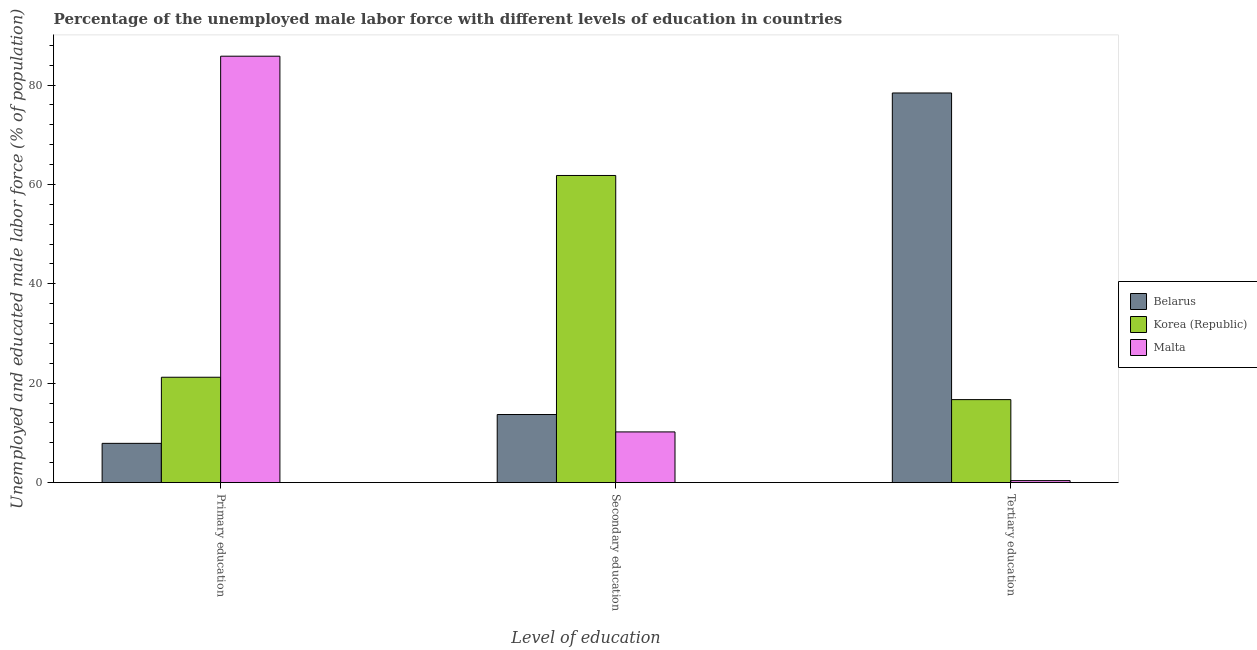How many groups of bars are there?
Your response must be concise. 3. Are the number of bars per tick equal to the number of legend labels?
Keep it short and to the point. Yes. Are the number of bars on each tick of the X-axis equal?
Your answer should be very brief. Yes. How many bars are there on the 1st tick from the left?
Ensure brevity in your answer.  3. How many bars are there on the 2nd tick from the right?
Your response must be concise. 3. What is the label of the 3rd group of bars from the left?
Provide a succinct answer. Tertiary education. What is the percentage of male labor force who received tertiary education in Belarus?
Provide a short and direct response. 78.4. Across all countries, what is the maximum percentage of male labor force who received secondary education?
Ensure brevity in your answer.  61.8. Across all countries, what is the minimum percentage of male labor force who received tertiary education?
Your response must be concise. 0.4. In which country was the percentage of male labor force who received secondary education minimum?
Give a very brief answer. Malta. What is the total percentage of male labor force who received primary education in the graph?
Ensure brevity in your answer.  114.9. What is the difference between the percentage of male labor force who received tertiary education in Korea (Republic) and that in Malta?
Make the answer very short. 16.3. What is the difference between the percentage of male labor force who received secondary education in Korea (Republic) and the percentage of male labor force who received tertiary education in Malta?
Make the answer very short. 61.4. What is the average percentage of male labor force who received secondary education per country?
Your response must be concise. 28.57. What is the difference between the percentage of male labor force who received primary education and percentage of male labor force who received tertiary education in Malta?
Make the answer very short. 85.4. In how many countries, is the percentage of male labor force who received secondary education greater than 44 %?
Give a very brief answer. 1. What is the ratio of the percentage of male labor force who received primary education in Malta to that in Korea (Republic)?
Your response must be concise. 4.05. Is the percentage of male labor force who received primary education in Belarus less than that in Korea (Republic)?
Provide a succinct answer. Yes. Is the difference between the percentage of male labor force who received primary education in Korea (Republic) and Malta greater than the difference between the percentage of male labor force who received secondary education in Korea (Republic) and Malta?
Provide a succinct answer. No. What is the difference between the highest and the second highest percentage of male labor force who received tertiary education?
Offer a very short reply. 61.7. What is the difference between the highest and the lowest percentage of male labor force who received primary education?
Keep it short and to the point. 77.9. Is the sum of the percentage of male labor force who received tertiary education in Malta and Belarus greater than the maximum percentage of male labor force who received primary education across all countries?
Your answer should be compact. No. What does the 3rd bar from the left in Secondary education represents?
Your answer should be very brief. Malta. What does the 1st bar from the right in Secondary education represents?
Keep it short and to the point. Malta. Is it the case that in every country, the sum of the percentage of male labor force who received primary education and percentage of male labor force who received secondary education is greater than the percentage of male labor force who received tertiary education?
Your answer should be very brief. No. How many bars are there?
Give a very brief answer. 9. How many countries are there in the graph?
Provide a short and direct response. 3. What is the difference between two consecutive major ticks on the Y-axis?
Your response must be concise. 20. Are the values on the major ticks of Y-axis written in scientific E-notation?
Offer a terse response. No. Where does the legend appear in the graph?
Keep it short and to the point. Center right. What is the title of the graph?
Offer a very short reply. Percentage of the unemployed male labor force with different levels of education in countries. Does "North America" appear as one of the legend labels in the graph?
Offer a terse response. No. What is the label or title of the X-axis?
Offer a very short reply. Level of education. What is the label or title of the Y-axis?
Your answer should be very brief. Unemployed and educated male labor force (% of population). What is the Unemployed and educated male labor force (% of population) in Belarus in Primary education?
Ensure brevity in your answer.  7.9. What is the Unemployed and educated male labor force (% of population) in Korea (Republic) in Primary education?
Your answer should be very brief. 21.2. What is the Unemployed and educated male labor force (% of population) in Malta in Primary education?
Keep it short and to the point. 85.8. What is the Unemployed and educated male labor force (% of population) in Belarus in Secondary education?
Ensure brevity in your answer.  13.7. What is the Unemployed and educated male labor force (% of population) of Korea (Republic) in Secondary education?
Provide a short and direct response. 61.8. What is the Unemployed and educated male labor force (% of population) of Malta in Secondary education?
Ensure brevity in your answer.  10.2. What is the Unemployed and educated male labor force (% of population) in Belarus in Tertiary education?
Provide a succinct answer. 78.4. What is the Unemployed and educated male labor force (% of population) in Korea (Republic) in Tertiary education?
Your answer should be compact. 16.7. What is the Unemployed and educated male labor force (% of population) of Malta in Tertiary education?
Your response must be concise. 0.4. Across all Level of education, what is the maximum Unemployed and educated male labor force (% of population) in Belarus?
Your answer should be compact. 78.4. Across all Level of education, what is the maximum Unemployed and educated male labor force (% of population) of Korea (Republic)?
Your response must be concise. 61.8. Across all Level of education, what is the maximum Unemployed and educated male labor force (% of population) of Malta?
Your answer should be very brief. 85.8. Across all Level of education, what is the minimum Unemployed and educated male labor force (% of population) in Belarus?
Make the answer very short. 7.9. Across all Level of education, what is the minimum Unemployed and educated male labor force (% of population) of Korea (Republic)?
Ensure brevity in your answer.  16.7. Across all Level of education, what is the minimum Unemployed and educated male labor force (% of population) in Malta?
Offer a very short reply. 0.4. What is the total Unemployed and educated male labor force (% of population) of Korea (Republic) in the graph?
Give a very brief answer. 99.7. What is the total Unemployed and educated male labor force (% of population) of Malta in the graph?
Keep it short and to the point. 96.4. What is the difference between the Unemployed and educated male labor force (% of population) in Korea (Republic) in Primary education and that in Secondary education?
Your answer should be compact. -40.6. What is the difference between the Unemployed and educated male labor force (% of population) of Malta in Primary education and that in Secondary education?
Provide a succinct answer. 75.6. What is the difference between the Unemployed and educated male labor force (% of population) in Belarus in Primary education and that in Tertiary education?
Provide a succinct answer. -70.5. What is the difference between the Unemployed and educated male labor force (% of population) of Korea (Republic) in Primary education and that in Tertiary education?
Ensure brevity in your answer.  4.5. What is the difference between the Unemployed and educated male labor force (% of population) in Malta in Primary education and that in Tertiary education?
Your response must be concise. 85.4. What is the difference between the Unemployed and educated male labor force (% of population) of Belarus in Secondary education and that in Tertiary education?
Make the answer very short. -64.7. What is the difference between the Unemployed and educated male labor force (% of population) of Korea (Republic) in Secondary education and that in Tertiary education?
Offer a terse response. 45.1. What is the difference between the Unemployed and educated male labor force (% of population) of Belarus in Primary education and the Unemployed and educated male labor force (% of population) of Korea (Republic) in Secondary education?
Make the answer very short. -53.9. What is the difference between the Unemployed and educated male labor force (% of population) in Korea (Republic) in Primary education and the Unemployed and educated male labor force (% of population) in Malta in Secondary education?
Make the answer very short. 11. What is the difference between the Unemployed and educated male labor force (% of population) of Korea (Republic) in Primary education and the Unemployed and educated male labor force (% of population) of Malta in Tertiary education?
Offer a very short reply. 20.8. What is the difference between the Unemployed and educated male labor force (% of population) in Korea (Republic) in Secondary education and the Unemployed and educated male labor force (% of population) in Malta in Tertiary education?
Ensure brevity in your answer.  61.4. What is the average Unemployed and educated male labor force (% of population) of Belarus per Level of education?
Ensure brevity in your answer.  33.33. What is the average Unemployed and educated male labor force (% of population) of Korea (Republic) per Level of education?
Make the answer very short. 33.23. What is the average Unemployed and educated male labor force (% of population) in Malta per Level of education?
Your answer should be very brief. 32.13. What is the difference between the Unemployed and educated male labor force (% of population) of Belarus and Unemployed and educated male labor force (% of population) of Malta in Primary education?
Ensure brevity in your answer.  -77.9. What is the difference between the Unemployed and educated male labor force (% of population) in Korea (Republic) and Unemployed and educated male labor force (% of population) in Malta in Primary education?
Give a very brief answer. -64.6. What is the difference between the Unemployed and educated male labor force (% of population) of Belarus and Unemployed and educated male labor force (% of population) of Korea (Republic) in Secondary education?
Provide a short and direct response. -48.1. What is the difference between the Unemployed and educated male labor force (% of population) of Belarus and Unemployed and educated male labor force (% of population) of Malta in Secondary education?
Your answer should be compact. 3.5. What is the difference between the Unemployed and educated male labor force (% of population) of Korea (Republic) and Unemployed and educated male labor force (% of population) of Malta in Secondary education?
Keep it short and to the point. 51.6. What is the difference between the Unemployed and educated male labor force (% of population) in Belarus and Unemployed and educated male labor force (% of population) in Korea (Republic) in Tertiary education?
Your answer should be very brief. 61.7. What is the difference between the Unemployed and educated male labor force (% of population) of Korea (Republic) and Unemployed and educated male labor force (% of population) of Malta in Tertiary education?
Offer a very short reply. 16.3. What is the ratio of the Unemployed and educated male labor force (% of population) in Belarus in Primary education to that in Secondary education?
Your answer should be compact. 0.58. What is the ratio of the Unemployed and educated male labor force (% of population) in Korea (Republic) in Primary education to that in Secondary education?
Make the answer very short. 0.34. What is the ratio of the Unemployed and educated male labor force (% of population) of Malta in Primary education to that in Secondary education?
Make the answer very short. 8.41. What is the ratio of the Unemployed and educated male labor force (% of population) of Belarus in Primary education to that in Tertiary education?
Your answer should be compact. 0.1. What is the ratio of the Unemployed and educated male labor force (% of population) in Korea (Republic) in Primary education to that in Tertiary education?
Offer a terse response. 1.27. What is the ratio of the Unemployed and educated male labor force (% of population) in Malta in Primary education to that in Tertiary education?
Offer a very short reply. 214.5. What is the ratio of the Unemployed and educated male labor force (% of population) in Belarus in Secondary education to that in Tertiary education?
Keep it short and to the point. 0.17. What is the ratio of the Unemployed and educated male labor force (% of population) in Korea (Republic) in Secondary education to that in Tertiary education?
Make the answer very short. 3.7. What is the ratio of the Unemployed and educated male labor force (% of population) of Malta in Secondary education to that in Tertiary education?
Give a very brief answer. 25.5. What is the difference between the highest and the second highest Unemployed and educated male labor force (% of population) in Belarus?
Ensure brevity in your answer.  64.7. What is the difference between the highest and the second highest Unemployed and educated male labor force (% of population) in Korea (Republic)?
Your answer should be very brief. 40.6. What is the difference between the highest and the second highest Unemployed and educated male labor force (% of population) in Malta?
Make the answer very short. 75.6. What is the difference between the highest and the lowest Unemployed and educated male labor force (% of population) of Belarus?
Provide a succinct answer. 70.5. What is the difference between the highest and the lowest Unemployed and educated male labor force (% of population) in Korea (Republic)?
Your answer should be very brief. 45.1. What is the difference between the highest and the lowest Unemployed and educated male labor force (% of population) of Malta?
Provide a short and direct response. 85.4. 